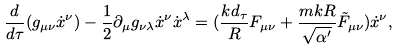<formula> <loc_0><loc_0><loc_500><loc_500>\frac { d } { d \tau } ( g _ { \mu \nu } { \dot { x } } ^ { \nu } ) - \frac { 1 } { 2 } \partial _ { \mu } g _ { \nu \lambda } { \dot { x } } ^ { \nu } { \dot { x } } ^ { \lambda } = ( \frac { k d _ { \tau } } { R } F _ { \mu \nu } + \frac { m k R } { \sqrt { \alpha ^ { \prime } } } \tilde { F } _ { \mu \nu } ) { \dot { x } } ^ { \nu } ,</formula> 